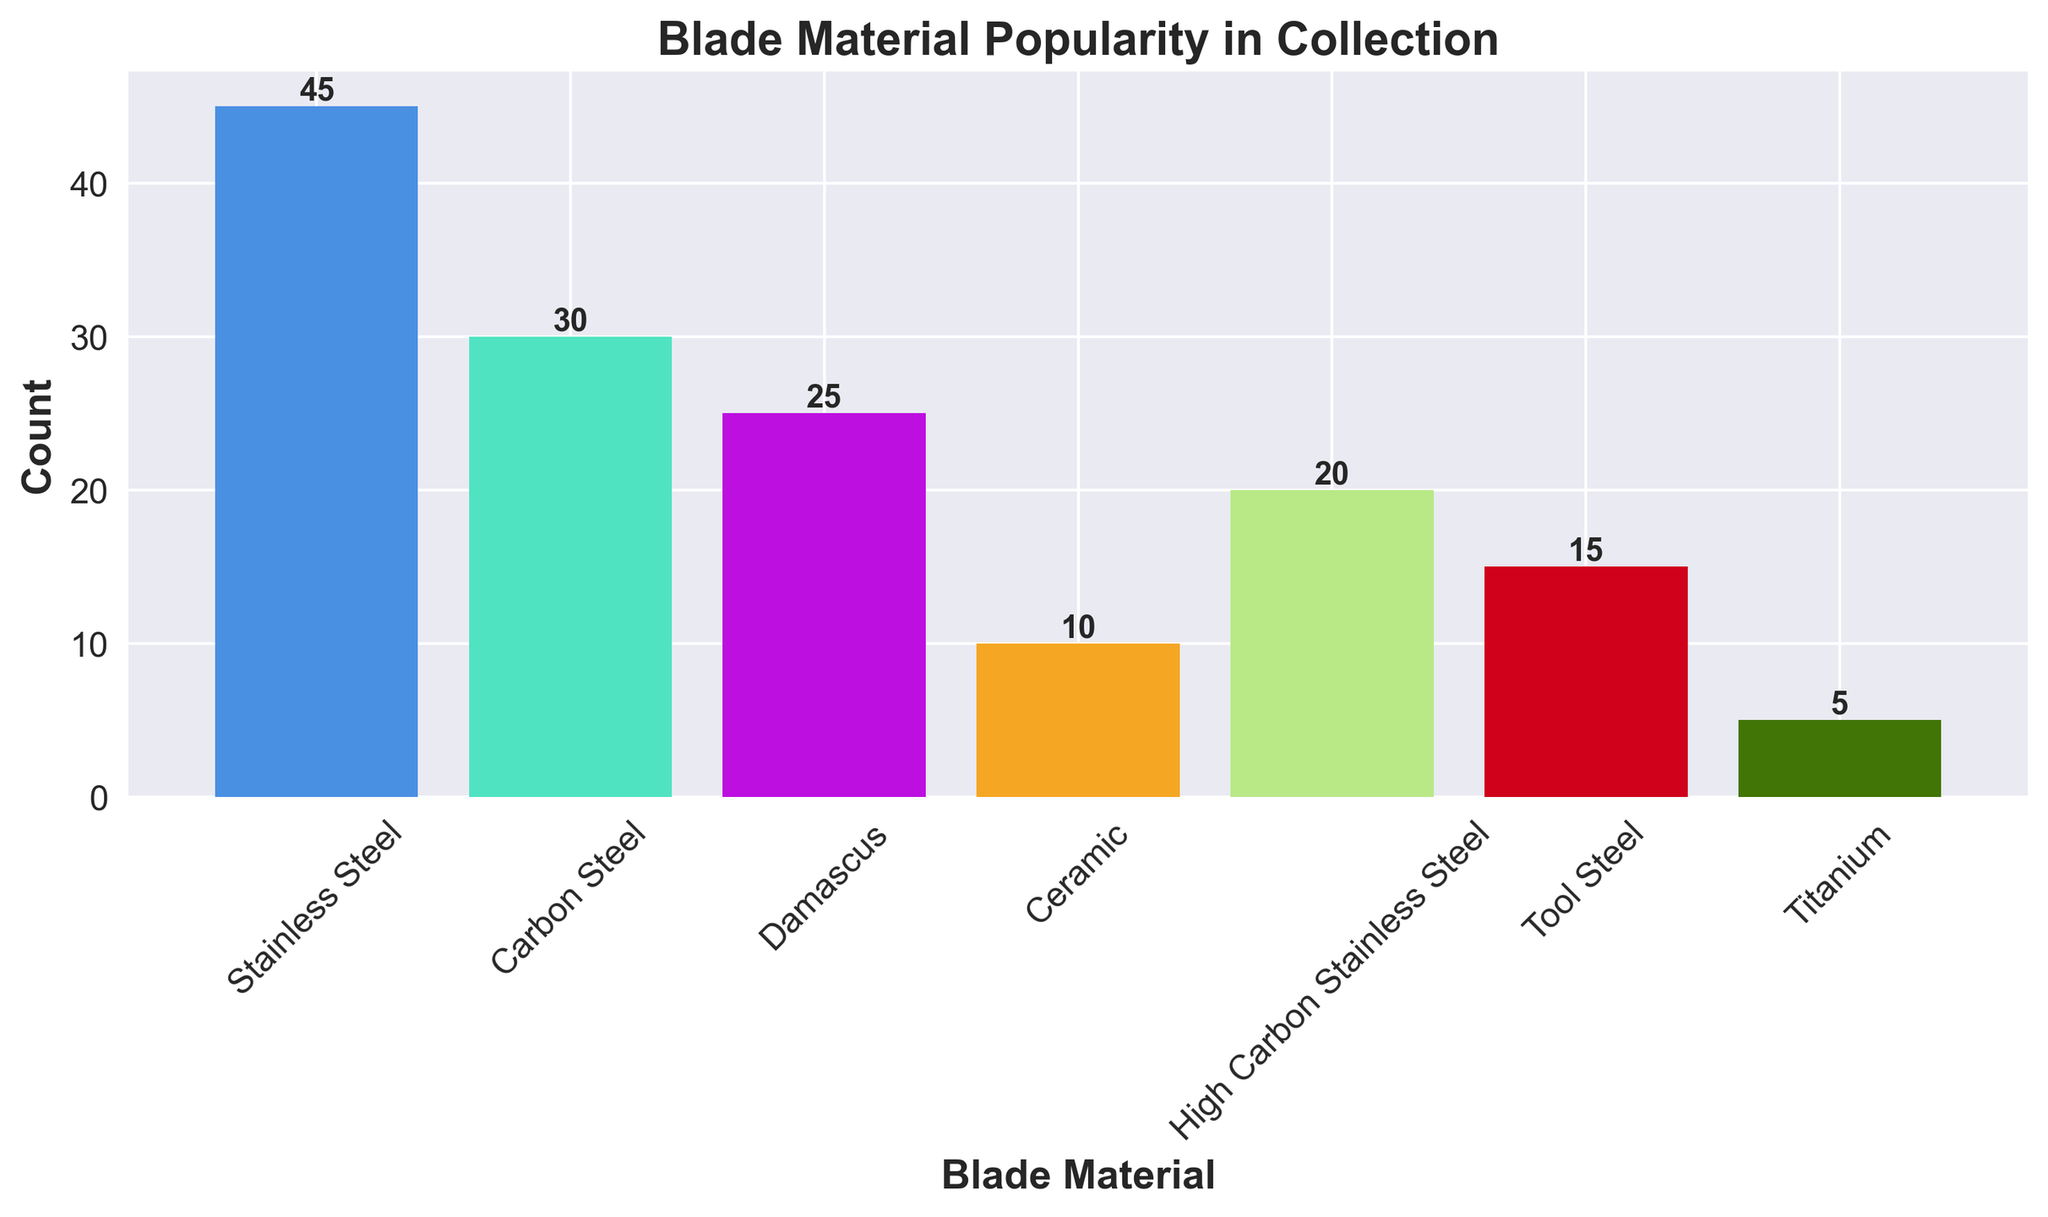Which blade material is the most popular in the collection? The tallest bar on the chart visually represents the count of the most popular blade material. "Stainless Steel" has the tallest bar.
Answer: Stainless Steel What is the count of Damascus blade materials in the collection? The bar labeled "Damascus" is annotated with its count value. The annotation shows the count as 25.
Answer: 25 What is the difference in count between Carbon Steel and Tool Steel blade materials? The height of the bars for Carbon Steel and Tool Steel shows their counts: 30 and 15, respectively. Subtracting these counts, 30 - 15, gives 15.
Answer: 15 Which blade material has the least popularity in the collection? The bar with the shortest height represents the least popular blade material. The shortest bar is for "Titanium" with a count of 5.
Answer: Titanium What is the total count of Carbon Steel, High Carbon Stainless Steel, and Tool Steel blade materials combined? Sum the counts of Carbon Steel (30), High Carbon Stainless Steel (20), and Tool Steel (15) to find the total: 30 + 20 + 15 = 65.
Answer: 65 How does the count of Ceramic blade materials compare to High Carbon Stainless Steel blade materials? Compare the heights of the bars. The count for Ceramic is 10, while High Carbon Stainless Steel has a count of 20. Therefore, Ceramic is less popular.
Answer: Less popular What's the ratio of Stainless Steel blades to Titanium blades? The count of Stainless Steel blades is 45, and the count of Titanium blades is 5. Dividing 45 by 5 gives a ratio of 9:1.
Answer: 9:1 How many more Stainless Steel blades are there than Damascus blades? Subtract the count of Damascus (25) from the count of Stainless Steel (45): 45 - 25 = 20.
Answer: 20 Which blade materials have a count greater than 20? Identify bars with counts greater than 20: Stainless Steel (45), Carbon Steel (30), and High Carbon Stainless Steel (20).
Answer: Stainless Steel, Carbon Steel 